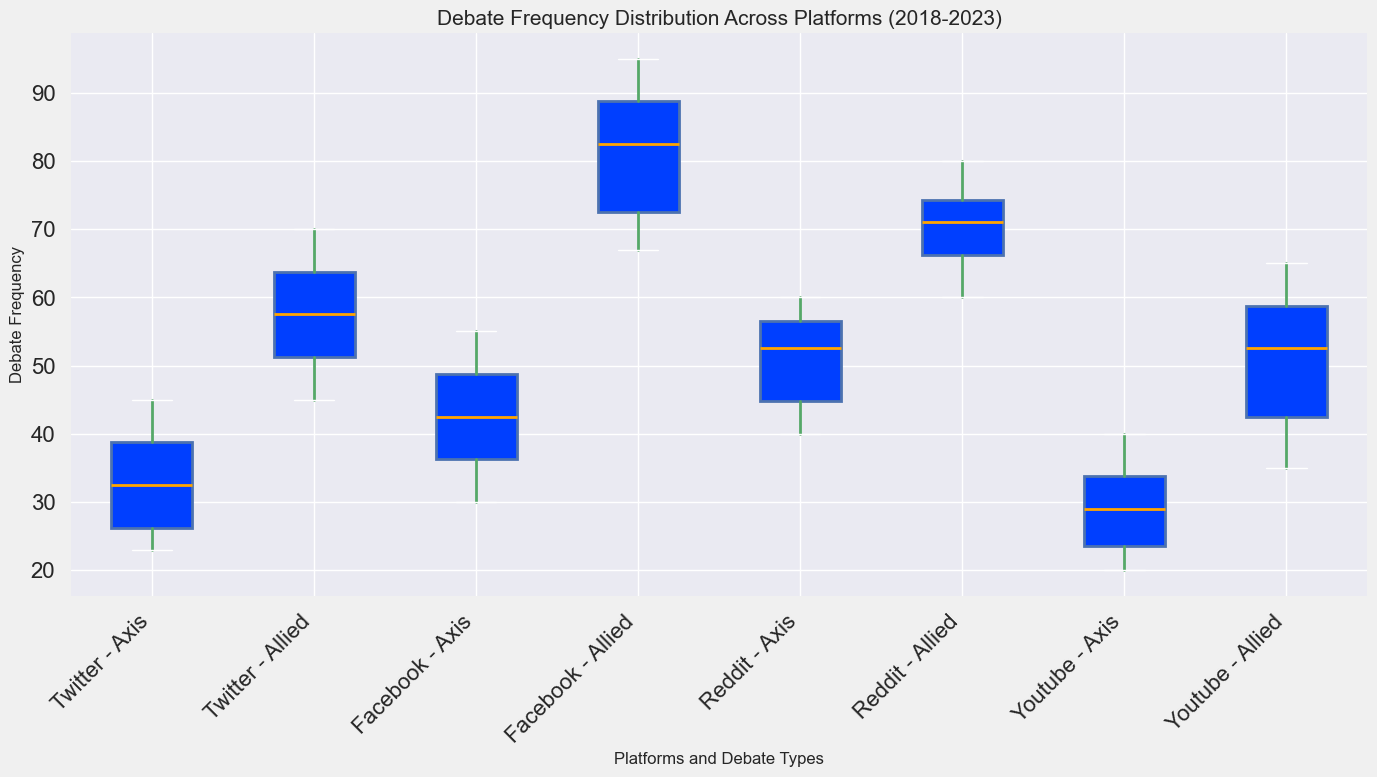What is the median debate frequency for Axis debates on Reddit? To find the median, we list the Axis debate frequencies for Reddit over the years: [40, 43, 50, 55, 57, 60]. Since there are six values, the median is the average of the middle two values (50 and 55), which is (50 + 55) / 2 = 52.5.
Answer: 52.5 Between Twitter and Facebook, which platform has the higher median debate frequency for Allied debates? For Allied debates, the median for Twitter (45, 50, 55, 60, 65, 70) is 57.5. For Facebook (67, 70, 80, 85, 90, 95), the median is 82.5. Comparing the medians, Facebook has the higher median debate frequency for Allied debates.
Answer: Facebook What is the range of debate frequencies for Axis debates on Youtube? The range is calculated as the difference between the maximum and minimum values of Axis debates on Youtube. The values are [22, 20, 28, 30, 35, 40], so the range is 40 - 20 = 20.
Answer: 20 Compare the interquartile ranges (IQR) of Allied debates across Reddit and Twitter. Which one is larger? The IQR is calculated as the difference between the third quartile (Q3) and the first quartile (Q1). For Reddit: Q1 is 65 and Q3 is 75, so IQR = 75 - 65 = 10. For Twitter: Q1 is 50 and Q3 is 65, so IQR = 65 - 50 = 15. The IQR for Twitter is larger.
Answer: Twitter Which platform shows the highest upper whisker value for Allied debates? The upper whisker corresponds to the maximum value, excluding outliers. Reviewing the plot, Facebook's upper whisker reaches the highest value at 95.
Answer: Facebook Do Axis or Allied debates on Facebook have more variability in debate frequency? Variability can be assessed by looking at the box sizes and whiskers. For Allied debates on Facebook, the box and whiskers are generally longer compared to Axis debates. This indicates higher variability for Allied debates.
Answer: Allied debates Do any platforms show outliers for Axis debates? If so, which ones? Outliers are typically represented by points outside the whiskers. Reviewing the plot for Axis debates, there are no platforms that display outliers visually represented by points.
Answer: None What is the general trend for median Axis debate frequencies over the years across all platforms? Observing the medians for each platform (Twitter, Facebook, Reddit, Youtube) over the years from the boxes' horizontal line, we notice that the median values generally increase over time.
Answer: Increasing Are there any platforms where the median debate frequency for Axis debates is equal to the median for Allied debates? Observing the median lines within the boxes for each platform, there are no platforms where both the Axis and Allied boxes have the same median line.
Answer: No Which platform has the smallest interquartile range (IQR) for Axis debates? Reviewing the box sizes for Axis debates, the smallest box corresponds to Youtube, indicating that Youtube has the smallest IQR for Axis debates.
Answer: Youtube 